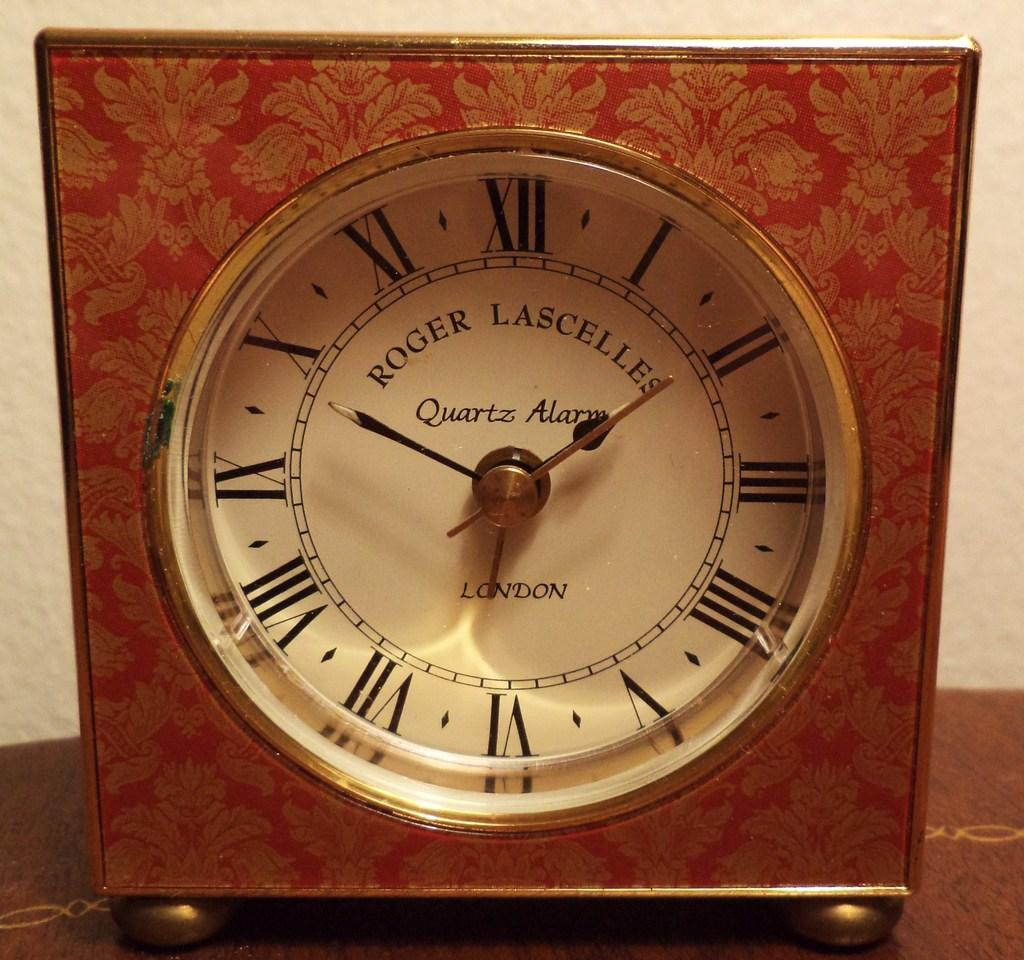What object in the image can be used to tell time? There is a clock in the image that can be used to tell time. What can be seen in the background of the image? There is a wall in the background of the image. How many boys are involved in the kissing scene in the image? There is no kissing scene or boys present in the image; it only features a clock and a wall. 